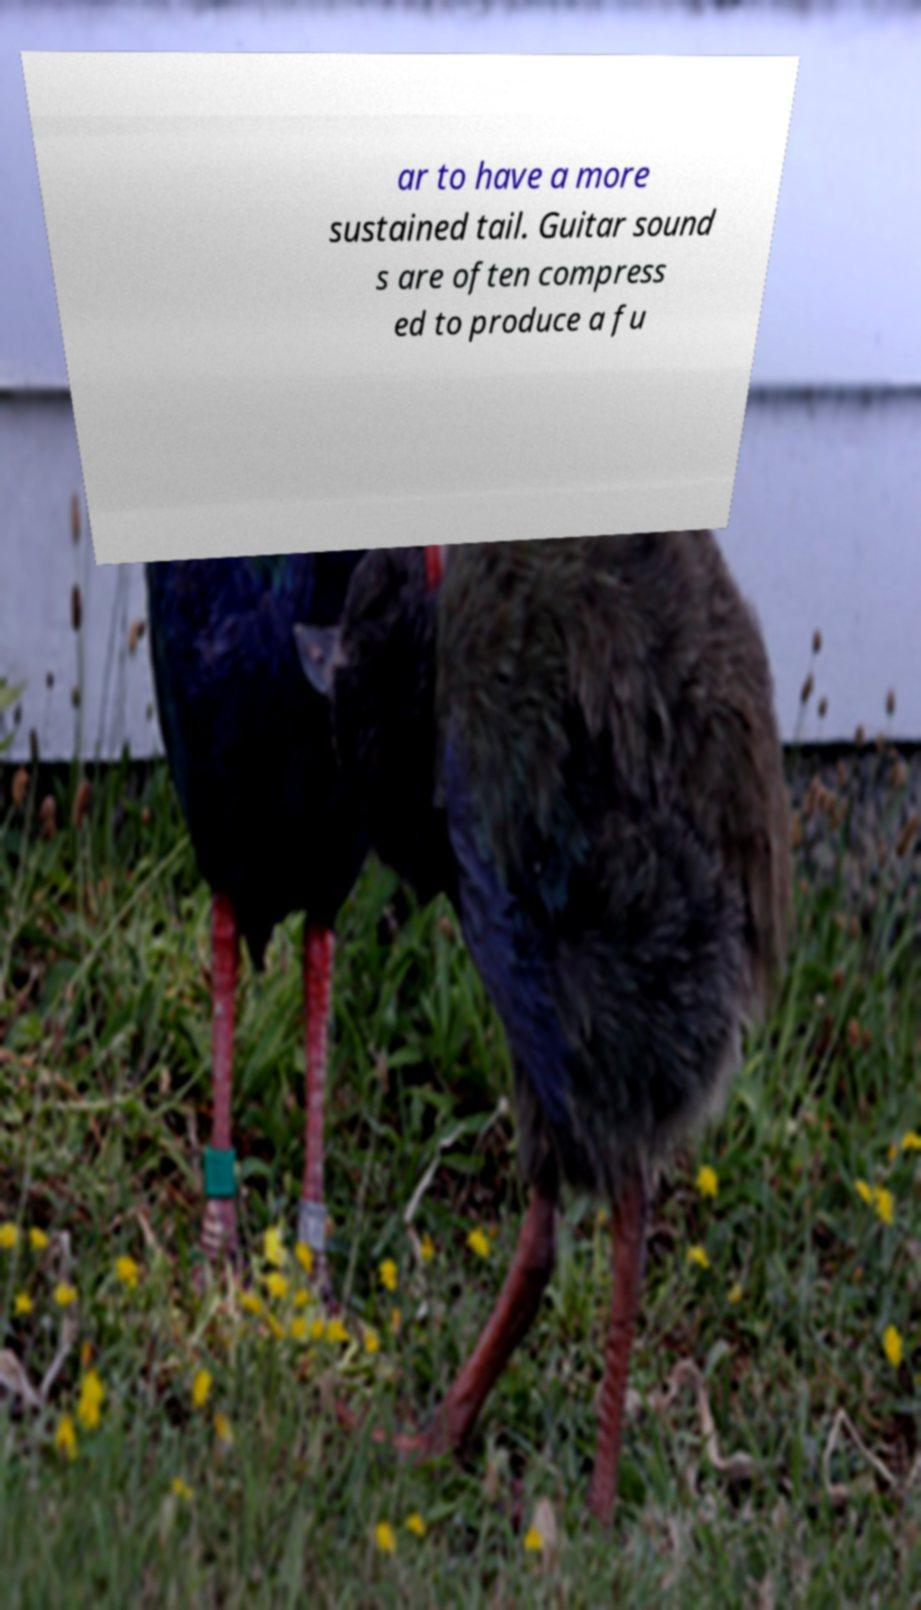For documentation purposes, I need the text within this image transcribed. Could you provide that? ar to have a more sustained tail. Guitar sound s are often compress ed to produce a fu 